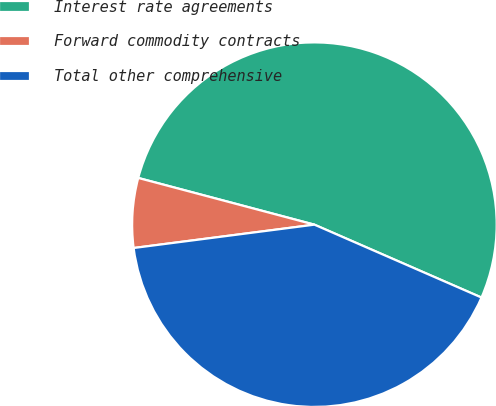Convert chart. <chart><loc_0><loc_0><loc_500><loc_500><pie_chart><fcel>Interest rate agreements<fcel>Forward commodity contracts<fcel>Total other comprehensive<nl><fcel>52.42%<fcel>6.17%<fcel>41.41%<nl></chart> 